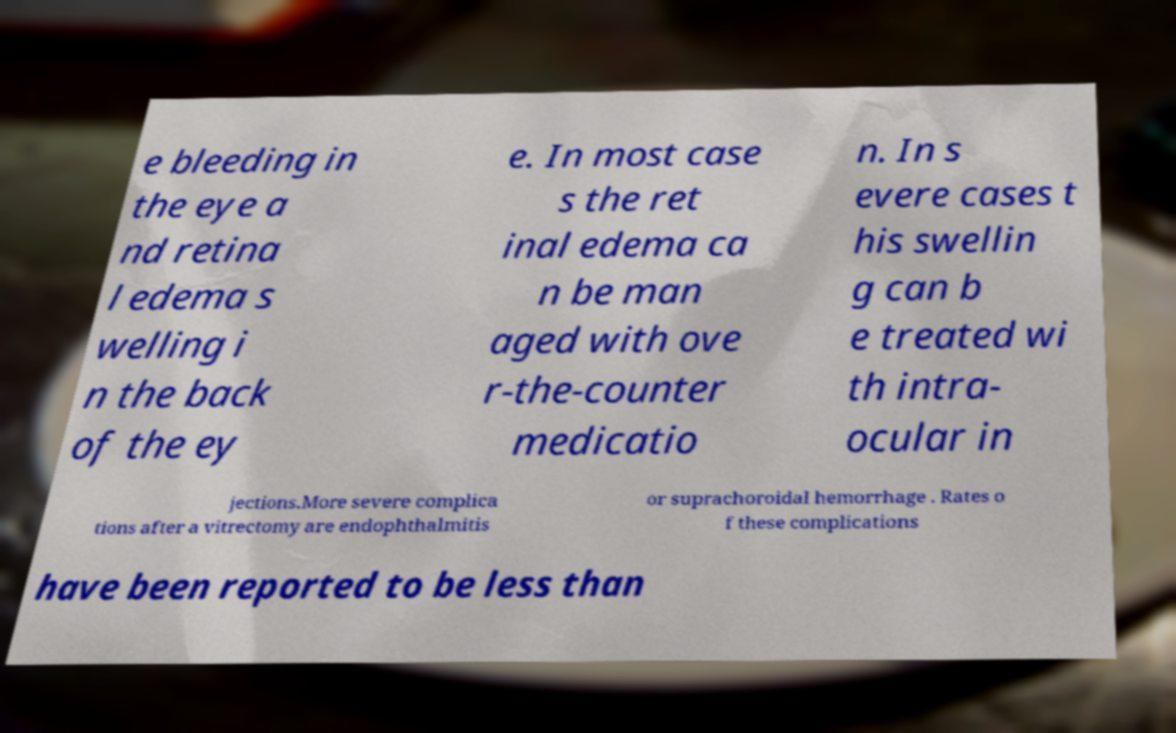There's text embedded in this image that I need extracted. Can you transcribe it verbatim? e bleeding in the eye a nd retina l edema s welling i n the back of the ey e. In most case s the ret inal edema ca n be man aged with ove r-the-counter medicatio n. In s evere cases t his swellin g can b e treated wi th intra- ocular in jections.More severe complica tions after a vitrectomy are endophthalmitis or suprachoroidal hemorrhage . Rates o f these complications have been reported to be less than 